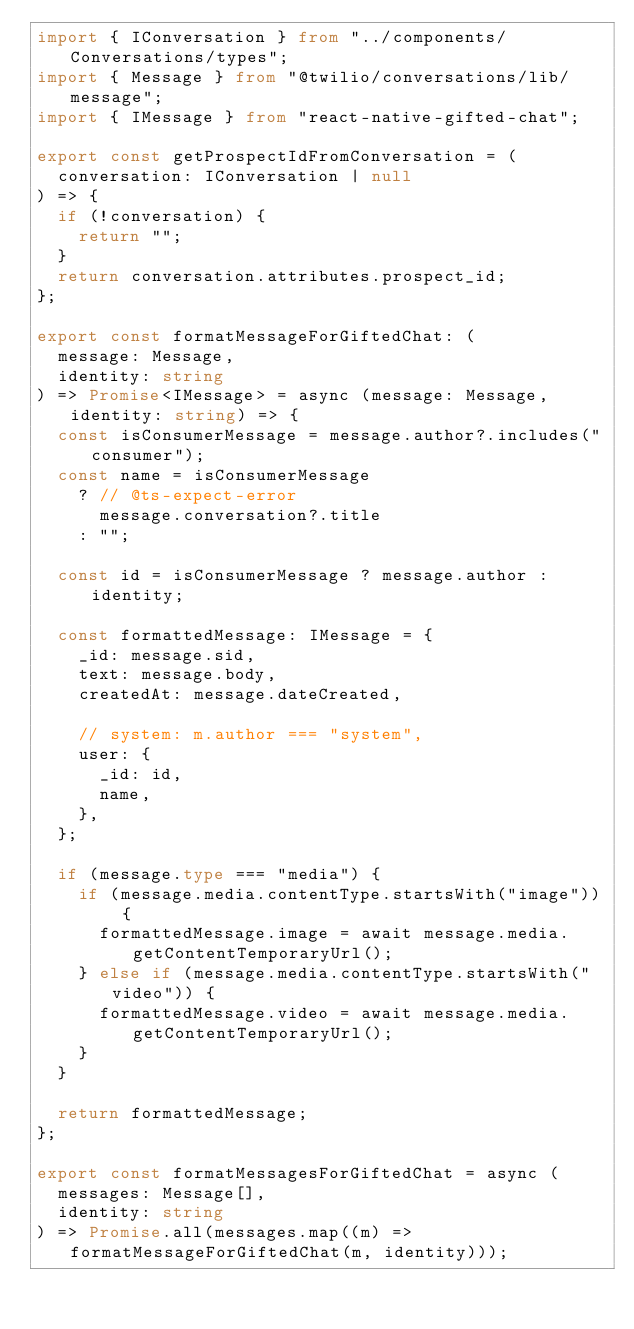<code> <loc_0><loc_0><loc_500><loc_500><_TypeScript_>import { IConversation } from "../components/Conversations/types";
import { Message } from "@twilio/conversations/lib/message";
import { IMessage } from "react-native-gifted-chat";

export const getProspectIdFromConversation = (
  conversation: IConversation | null
) => {
  if (!conversation) {
    return "";
  }
  return conversation.attributes.prospect_id;
};

export const formatMessageForGiftedChat: (
  message: Message,
  identity: string
) => Promise<IMessage> = async (message: Message, identity: string) => {
  const isConsumerMessage = message.author?.includes("consumer");
  const name = isConsumerMessage
    ? // @ts-expect-error
      message.conversation?.title
    : "";

  const id = isConsumerMessage ? message.author : identity;

  const formattedMessage: IMessage = {
    _id: message.sid,
    text: message.body,
    createdAt: message.dateCreated,

    // system: m.author === "system",
    user: {
      _id: id,
      name,
    },
  };

  if (message.type === "media") {
    if (message.media.contentType.startsWith("image")) {
      formattedMessage.image = await message.media.getContentTemporaryUrl();
    } else if (message.media.contentType.startsWith("video")) {
      formattedMessage.video = await message.media.getContentTemporaryUrl();
    }
  }

  return formattedMessage;
};

export const formatMessagesForGiftedChat = async (
  messages: Message[],
  identity: string
) => Promise.all(messages.map((m) => formatMessageForGiftedChat(m, identity)));
</code> 